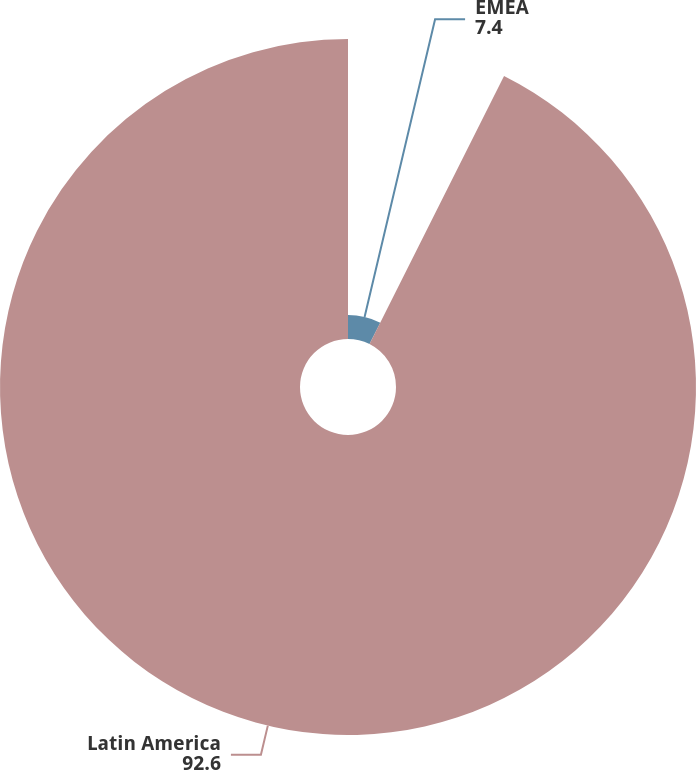Convert chart to OTSL. <chart><loc_0><loc_0><loc_500><loc_500><pie_chart><fcel>EMEA<fcel>Latin America<nl><fcel>7.4%<fcel>92.6%<nl></chart> 